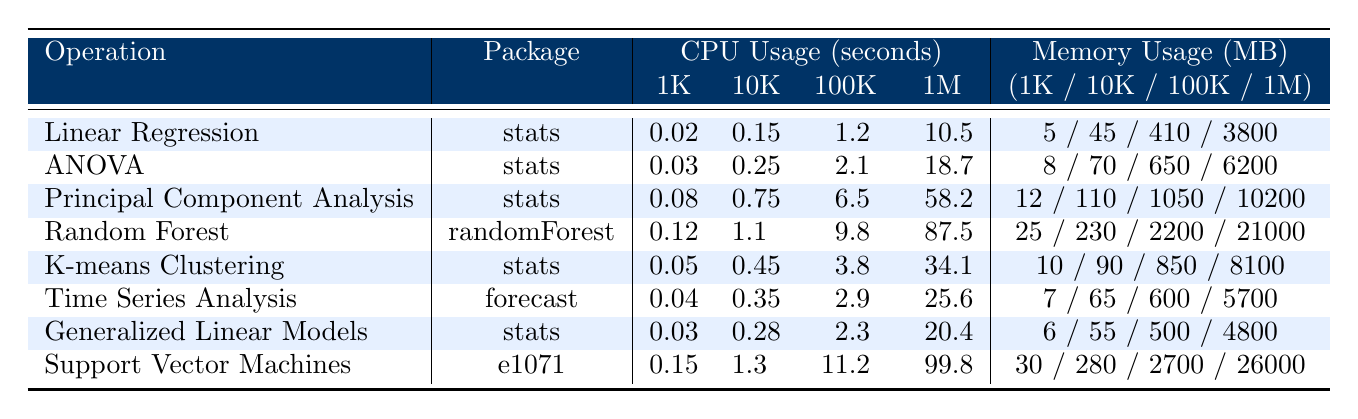What's the CPU usage for Random Forest with a sample size of 100,000? In the table, under the "CPU Usage (seconds)" column for "Random Forest", the value corresponding to a sample size of 100k is 9.8 seconds.
Answer: 9.8 seconds Which operation uses the least amount of memory for a sample size of 1,000? Looking at the "Memory Usage (MB)" column with the sample size 1K, "Linear Regression" has the lowest memory usage at 5 MB.
Answer: 5 MB What is the total CPU usage for Support Vector Machines across all sample sizes? To find the total, you sum the CPU usage values for "Support Vector Machines": 0.15 + 1.3 + 11.2 + 99.8 = 112.5 seconds.
Answer: 112.5 seconds Is the memory usage for K-means Clustering more than for ANOVA at a sample size of 10,000? For "K-means Clustering", the memory usage at 10K is 90 MB, while for "ANOVA", it is 70 MB. Since 90 is more than 70, the statement is true.
Answer: Yes What is the difference in CPU usage between Principal Component Analysis and Time Series Analysis when the sample size is 100,000? For "Principal Component Analysis" at 100K, the CPU usage is 6.5 seconds, and for "Time Series Analysis", it is 2.9 seconds. The difference is 6.5 - 2.9 = 3.6 seconds.
Answer: 3.6 seconds Which operation has the highest CPU usage at a sample size of 1,000,000? In the table for a sample size of 1M, we check the CPU usage for each operation. "Support Vector Machines" has the highest value at 99.8 seconds.
Answer: Support Vector Machines What is the average memory usage for all operations at a sample size of 100,000? To calculate the average memory usage at 100K, sum the values: 410 + 650 + 1050 + 2200 + 850 + 600 + 500 + 2700 = 10110 MB. There are 8 operations, so the average is 10110 / 8 = 1263.75 MB.
Answer: 1263.75 MB Do Principal Component Analysis and K-means Clustering use more than 1 second of CPU time for a sample size of 10,000? For "Principal Component Analysis", the CPU usage is 0.75 seconds; for "K-means Clustering", it is 0.45 seconds. Both are less than 1 second, so the statement is false.
Answer: No Which two operations have the closest memory usage at a sample size of 1,000,000? Comparing the memory usage for 1M, "Generalized Linear Models" is 4800 MB and "Time Series Analysis" is 5700 MB. The difference is 900 MB, which is smaller than any other operations' difference.
Answer: Generalized Linear Models and Time Series Analysis If we rank the operations by CPU usage at a sample size of 10,000, what is the rank of ANOVA? The CPU usages for 10K rank as follows from lowest to highest: Linear Regression (0.15), ANOVA (0.25), K-means Clustering (0.45), Time Series Analysis (0.35), Principal Component Analysis (0.75), Random Forest (1.1), Generalized Linear Models (0.28), Support Vector Machines (1.3). "ANOVA" ranks 2nd.
Answer: 2nd 